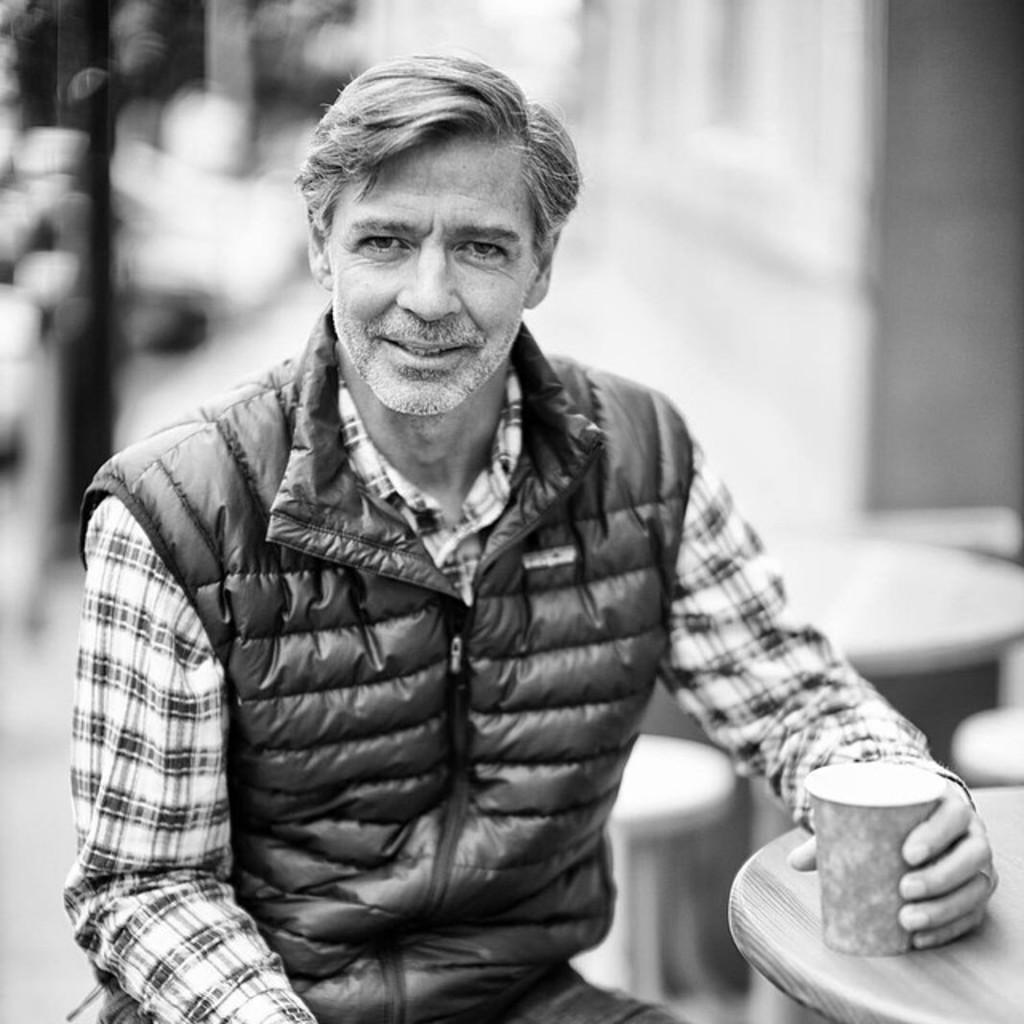In one or two sentences, can you explain what this image depicts? In the picture I can see a person wearing a jacket is sitting and holding a glass in his hand which is placed on the table in the right corner. 